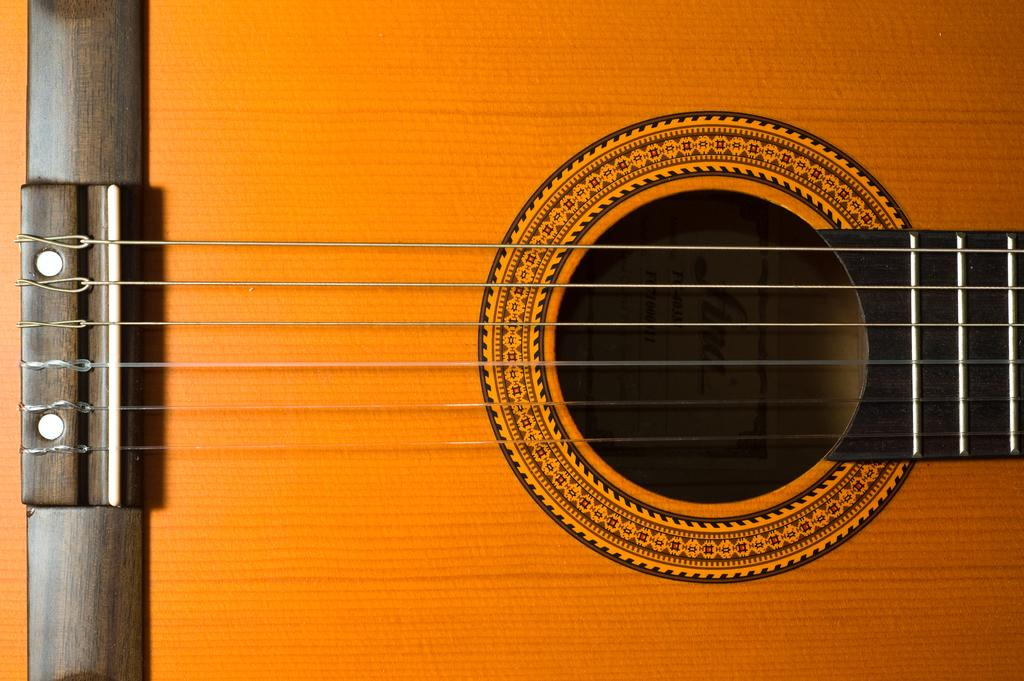What is the main subject of the image? The main subject of the image is a guitar. How many strings does the guitar have? The guitar has six strings. What can be observed about the strings in the image? The strings are straight from a point. What type of attention is the guitar receiving in the afternoon by the lake? The image does not mention any specific time of day, location, or attention being given to the guitar. 